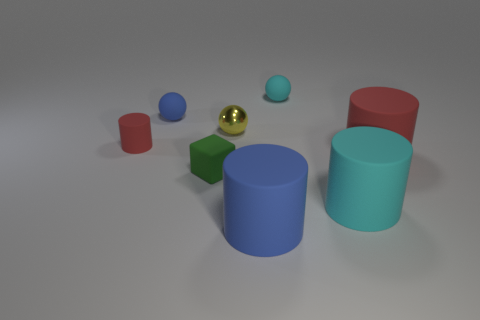Add 1 red things. How many objects exist? 9 Subtract all rubber spheres. How many spheres are left? 1 Add 5 large objects. How many large objects are left? 8 Add 7 tiny purple balls. How many tiny purple balls exist? 7 Subtract all cyan cylinders. How many cylinders are left? 3 Subtract 0 brown cylinders. How many objects are left? 8 Subtract all cubes. How many objects are left? 7 Subtract 4 cylinders. How many cylinders are left? 0 Subtract all blue spheres. Subtract all yellow cylinders. How many spheres are left? 2 Subtract all blue balls. How many red cylinders are left? 2 